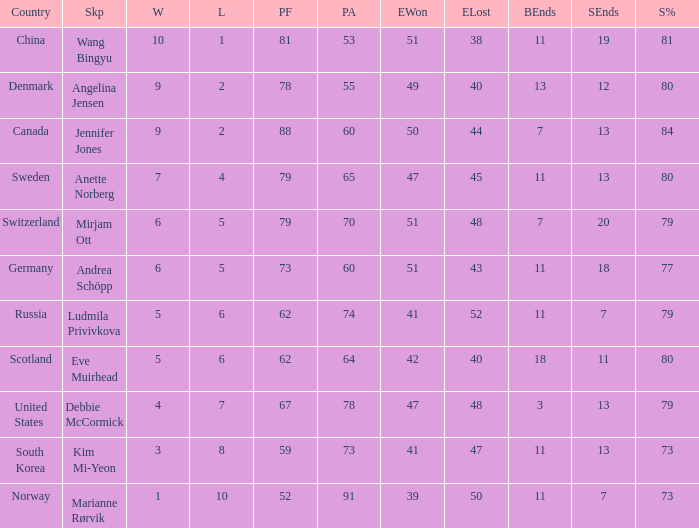What is the minimum Wins a team has? 1.0. 